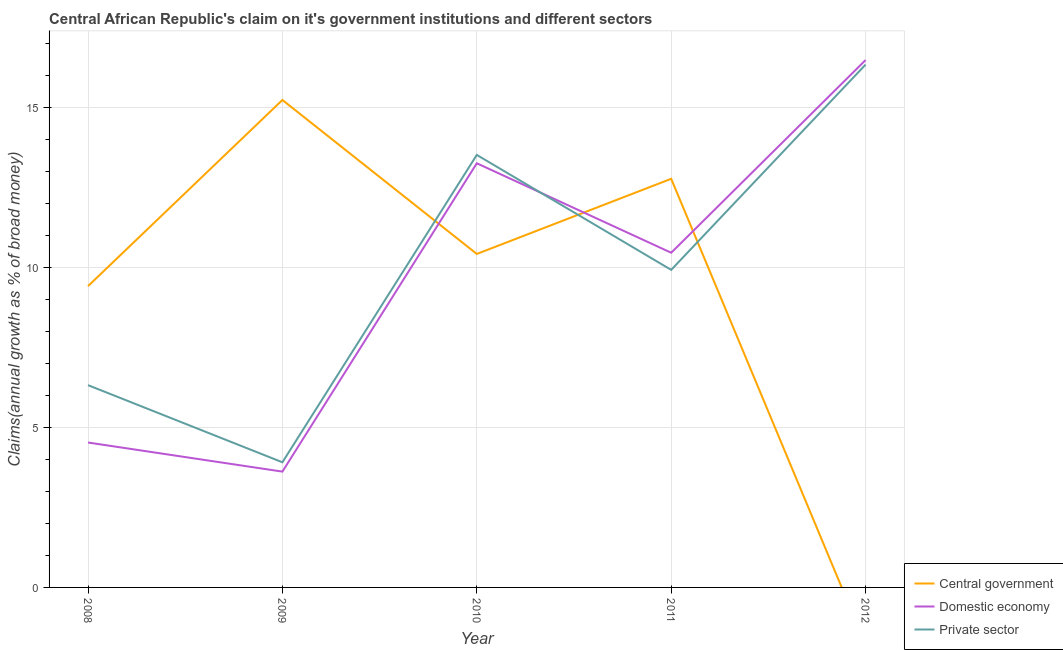What is the percentage of claim on the domestic economy in 2010?
Your answer should be compact. 13.27. Across all years, what is the maximum percentage of claim on the central government?
Provide a succinct answer. 15.25. Across all years, what is the minimum percentage of claim on the domestic economy?
Provide a short and direct response. 3.62. What is the total percentage of claim on the private sector in the graph?
Provide a succinct answer. 50.06. What is the difference between the percentage of claim on the domestic economy in 2008 and that in 2011?
Provide a succinct answer. -5.94. What is the difference between the percentage of claim on the central government in 2012 and the percentage of claim on the domestic economy in 2011?
Provide a short and direct response. -10.47. What is the average percentage of claim on the domestic economy per year?
Your response must be concise. 9.68. In the year 2011, what is the difference between the percentage of claim on the central government and percentage of claim on the domestic economy?
Provide a succinct answer. 2.31. In how many years, is the percentage of claim on the domestic economy greater than 9 %?
Offer a very short reply. 3. What is the ratio of the percentage of claim on the domestic economy in 2008 to that in 2009?
Offer a terse response. 1.25. Is the percentage of claim on the private sector in 2008 less than that in 2009?
Keep it short and to the point. No. What is the difference between the highest and the second highest percentage of claim on the private sector?
Your answer should be very brief. 2.83. What is the difference between the highest and the lowest percentage of claim on the domestic economy?
Give a very brief answer. 12.87. In how many years, is the percentage of claim on the domestic economy greater than the average percentage of claim on the domestic economy taken over all years?
Ensure brevity in your answer.  3. Does the percentage of claim on the central government monotonically increase over the years?
Keep it short and to the point. No. How many lines are there?
Make the answer very short. 3. What is the difference between two consecutive major ticks on the Y-axis?
Provide a succinct answer. 5. Are the values on the major ticks of Y-axis written in scientific E-notation?
Offer a terse response. No. Does the graph contain grids?
Ensure brevity in your answer.  Yes. How many legend labels are there?
Offer a terse response. 3. What is the title of the graph?
Give a very brief answer. Central African Republic's claim on it's government institutions and different sectors. What is the label or title of the X-axis?
Your response must be concise. Year. What is the label or title of the Y-axis?
Offer a terse response. Claims(annual growth as % of broad money). What is the Claims(annual growth as % of broad money) in Central government in 2008?
Give a very brief answer. 9.42. What is the Claims(annual growth as % of broad money) of Domestic economy in 2008?
Your response must be concise. 4.53. What is the Claims(annual growth as % of broad money) of Private sector in 2008?
Give a very brief answer. 6.33. What is the Claims(annual growth as % of broad money) of Central government in 2009?
Provide a succinct answer. 15.25. What is the Claims(annual growth as % of broad money) of Domestic economy in 2009?
Your answer should be very brief. 3.62. What is the Claims(annual growth as % of broad money) of Private sector in 2009?
Offer a terse response. 3.91. What is the Claims(annual growth as % of broad money) in Central government in 2010?
Provide a succinct answer. 10.43. What is the Claims(annual growth as % of broad money) in Domestic economy in 2010?
Provide a succinct answer. 13.27. What is the Claims(annual growth as % of broad money) in Private sector in 2010?
Make the answer very short. 13.53. What is the Claims(annual growth as % of broad money) of Central government in 2011?
Ensure brevity in your answer.  12.78. What is the Claims(annual growth as % of broad money) in Domestic economy in 2011?
Give a very brief answer. 10.47. What is the Claims(annual growth as % of broad money) in Private sector in 2011?
Provide a short and direct response. 9.93. What is the Claims(annual growth as % of broad money) in Central government in 2012?
Ensure brevity in your answer.  0. What is the Claims(annual growth as % of broad money) of Domestic economy in 2012?
Make the answer very short. 16.5. What is the Claims(annual growth as % of broad money) of Private sector in 2012?
Provide a short and direct response. 16.35. Across all years, what is the maximum Claims(annual growth as % of broad money) of Central government?
Your answer should be compact. 15.25. Across all years, what is the maximum Claims(annual growth as % of broad money) of Domestic economy?
Make the answer very short. 16.5. Across all years, what is the maximum Claims(annual growth as % of broad money) of Private sector?
Provide a succinct answer. 16.35. Across all years, what is the minimum Claims(annual growth as % of broad money) in Domestic economy?
Give a very brief answer. 3.62. Across all years, what is the minimum Claims(annual growth as % of broad money) in Private sector?
Ensure brevity in your answer.  3.91. What is the total Claims(annual growth as % of broad money) of Central government in the graph?
Your response must be concise. 47.88. What is the total Claims(annual growth as % of broad money) in Domestic economy in the graph?
Make the answer very short. 48.39. What is the total Claims(annual growth as % of broad money) in Private sector in the graph?
Ensure brevity in your answer.  50.06. What is the difference between the Claims(annual growth as % of broad money) of Central government in 2008 and that in 2009?
Provide a short and direct response. -5.82. What is the difference between the Claims(annual growth as % of broad money) of Domestic economy in 2008 and that in 2009?
Your answer should be compact. 0.91. What is the difference between the Claims(annual growth as % of broad money) of Private sector in 2008 and that in 2009?
Ensure brevity in your answer.  2.41. What is the difference between the Claims(annual growth as % of broad money) in Central government in 2008 and that in 2010?
Give a very brief answer. -1.01. What is the difference between the Claims(annual growth as % of broad money) of Domestic economy in 2008 and that in 2010?
Provide a short and direct response. -8.73. What is the difference between the Claims(annual growth as % of broad money) in Private sector in 2008 and that in 2010?
Your response must be concise. -7.2. What is the difference between the Claims(annual growth as % of broad money) of Central government in 2008 and that in 2011?
Give a very brief answer. -3.36. What is the difference between the Claims(annual growth as % of broad money) in Domestic economy in 2008 and that in 2011?
Your answer should be compact. -5.94. What is the difference between the Claims(annual growth as % of broad money) of Private sector in 2008 and that in 2011?
Provide a short and direct response. -3.61. What is the difference between the Claims(annual growth as % of broad money) in Domestic economy in 2008 and that in 2012?
Provide a succinct answer. -11.96. What is the difference between the Claims(annual growth as % of broad money) of Private sector in 2008 and that in 2012?
Provide a succinct answer. -10.03. What is the difference between the Claims(annual growth as % of broad money) in Central government in 2009 and that in 2010?
Provide a succinct answer. 4.82. What is the difference between the Claims(annual growth as % of broad money) of Domestic economy in 2009 and that in 2010?
Provide a short and direct response. -9.64. What is the difference between the Claims(annual growth as % of broad money) in Private sector in 2009 and that in 2010?
Offer a very short reply. -9.61. What is the difference between the Claims(annual growth as % of broad money) in Central government in 2009 and that in 2011?
Keep it short and to the point. 2.47. What is the difference between the Claims(annual growth as % of broad money) in Domestic economy in 2009 and that in 2011?
Your answer should be compact. -6.85. What is the difference between the Claims(annual growth as % of broad money) of Private sector in 2009 and that in 2011?
Make the answer very short. -6.02. What is the difference between the Claims(annual growth as % of broad money) of Domestic economy in 2009 and that in 2012?
Your answer should be compact. -12.87. What is the difference between the Claims(annual growth as % of broad money) of Private sector in 2009 and that in 2012?
Provide a succinct answer. -12.44. What is the difference between the Claims(annual growth as % of broad money) of Central government in 2010 and that in 2011?
Make the answer very short. -2.35. What is the difference between the Claims(annual growth as % of broad money) of Domestic economy in 2010 and that in 2011?
Make the answer very short. 2.8. What is the difference between the Claims(annual growth as % of broad money) in Private sector in 2010 and that in 2011?
Your answer should be very brief. 3.6. What is the difference between the Claims(annual growth as % of broad money) in Domestic economy in 2010 and that in 2012?
Your answer should be very brief. -3.23. What is the difference between the Claims(annual growth as % of broad money) in Private sector in 2010 and that in 2012?
Provide a short and direct response. -2.83. What is the difference between the Claims(annual growth as % of broad money) in Domestic economy in 2011 and that in 2012?
Make the answer very short. -6.03. What is the difference between the Claims(annual growth as % of broad money) in Private sector in 2011 and that in 2012?
Your response must be concise. -6.42. What is the difference between the Claims(annual growth as % of broad money) in Central government in 2008 and the Claims(annual growth as % of broad money) in Domestic economy in 2009?
Offer a terse response. 5.8. What is the difference between the Claims(annual growth as % of broad money) in Central government in 2008 and the Claims(annual growth as % of broad money) in Private sector in 2009?
Provide a short and direct response. 5.51. What is the difference between the Claims(annual growth as % of broad money) in Domestic economy in 2008 and the Claims(annual growth as % of broad money) in Private sector in 2009?
Provide a short and direct response. 0.62. What is the difference between the Claims(annual growth as % of broad money) in Central government in 2008 and the Claims(annual growth as % of broad money) in Domestic economy in 2010?
Ensure brevity in your answer.  -3.84. What is the difference between the Claims(annual growth as % of broad money) in Central government in 2008 and the Claims(annual growth as % of broad money) in Private sector in 2010?
Provide a succinct answer. -4.1. What is the difference between the Claims(annual growth as % of broad money) in Domestic economy in 2008 and the Claims(annual growth as % of broad money) in Private sector in 2010?
Give a very brief answer. -9. What is the difference between the Claims(annual growth as % of broad money) in Central government in 2008 and the Claims(annual growth as % of broad money) in Domestic economy in 2011?
Give a very brief answer. -1.04. What is the difference between the Claims(annual growth as % of broad money) in Central government in 2008 and the Claims(annual growth as % of broad money) in Private sector in 2011?
Ensure brevity in your answer.  -0.51. What is the difference between the Claims(annual growth as % of broad money) of Domestic economy in 2008 and the Claims(annual growth as % of broad money) of Private sector in 2011?
Your response must be concise. -5.4. What is the difference between the Claims(annual growth as % of broad money) of Central government in 2008 and the Claims(annual growth as % of broad money) of Domestic economy in 2012?
Offer a terse response. -7.07. What is the difference between the Claims(annual growth as % of broad money) of Central government in 2008 and the Claims(annual growth as % of broad money) of Private sector in 2012?
Provide a succinct answer. -6.93. What is the difference between the Claims(annual growth as % of broad money) in Domestic economy in 2008 and the Claims(annual growth as % of broad money) in Private sector in 2012?
Your response must be concise. -11.82. What is the difference between the Claims(annual growth as % of broad money) in Central government in 2009 and the Claims(annual growth as % of broad money) in Domestic economy in 2010?
Offer a very short reply. 1.98. What is the difference between the Claims(annual growth as % of broad money) in Central government in 2009 and the Claims(annual growth as % of broad money) in Private sector in 2010?
Offer a very short reply. 1.72. What is the difference between the Claims(annual growth as % of broad money) in Domestic economy in 2009 and the Claims(annual growth as % of broad money) in Private sector in 2010?
Offer a very short reply. -9.91. What is the difference between the Claims(annual growth as % of broad money) of Central government in 2009 and the Claims(annual growth as % of broad money) of Domestic economy in 2011?
Offer a very short reply. 4.78. What is the difference between the Claims(annual growth as % of broad money) in Central government in 2009 and the Claims(annual growth as % of broad money) in Private sector in 2011?
Give a very brief answer. 5.31. What is the difference between the Claims(annual growth as % of broad money) of Domestic economy in 2009 and the Claims(annual growth as % of broad money) of Private sector in 2011?
Offer a terse response. -6.31. What is the difference between the Claims(annual growth as % of broad money) of Central government in 2009 and the Claims(annual growth as % of broad money) of Domestic economy in 2012?
Provide a short and direct response. -1.25. What is the difference between the Claims(annual growth as % of broad money) of Central government in 2009 and the Claims(annual growth as % of broad money) of Private sector in 2012?
Provide a short and direct response. -1.11. What is the difference between the Claims(annual growth as % of broad money) in Domestic economy in 2009 and the Claims(annual growth as % of broad money) in Private sector in 2012?
Ensure brevity in your answer.  -12.73. What is the difference between the Claims(annual growth as % of broad money) of Central government in 2010 and the Claims(annual growth as % of broad money) of Domestic economy in 2011?
Provide a succinct answer. -0.04. What is the difference between the Claims(annual growth as % of broad money) in Central government in 2010 and the Claims(annual growth as % of broad money) in Private sector in 2011?
Offer a very short reply. 0.5. What is the difference between the Claims(annual growth as % of broad money) of Domestic economy in 2010 and the Claims(annual growth as % of broad money) of Private sector in 2011?
Make the answer very short. 3.33. What is the difference between the Claims(annual growth as % of broad money) of Central government in 2010 and the Claims(annual growth as % of broad money) of Domestic economy in 2012?
Make the answer very short. -6.06. What is the difference between the Claims(annual growth as % of broad money) of Central government in 2010 and the Claims(annual growth as % of broad money) of Private sector in 2012?
Your answer should be compact. -5.92. What is the difference between the Claims(annual growth as % of broad money) in Domestic economy in 2010 and the Claims(annual growth as % of broad money) in Private sector in 2012?
Provide a succinct answer. -3.09. What is the difference between the Claims(annual growth as % of broad money) of Central government in 2011 and the Claims(annual growth as % of broad money) of Domestic economy in 2012?
Ensure brevity in your answer.  -3.71. What is the difference between the Claims(annual growth as % of broad money) of Central government in 2011 and the Claims(annual growth as % of broad money) of Private sector in 2012?
Your answer should be compact. -3.57. What is the difference between the Claims(annual growth as % of broad money) of Domestic economy in 2011 and the Claims(annual growth as % of broad money) of Private sector in 2012?
Provide a succinct answer. -5.88. What is the average Claims(annual growth as % of broad money) in Central government per year?
Give a very brief answer. 9.58. What is the average Claims(annual growth as % of broad money) in Domestic economy per year?
Provide a short and direct response. 9.68. What is the average Claims(annual growth as % of broad money) in Private sector per year?
Give a very brief answer. 10.01. In the year 2008, what is the difference between the Claims(annual growth as % of broad money) in Central government and Claims(annual growth as % of broad money) in Domestic economy?
Provide a succinct answer. 4.89. In the year 2008, what is the difference between the Claims(annual growth as % of broad money) of Central government and Claims(annual growth as % of broad money) of Private sector?
Give a very brief answer. 3.1. In the year 2008, what is the difference between the Claims(annual growth as % of broad money) of Domestic economy and Claims(annual growth as % of broad money) of Private sector?
Make the answer very short. -1.79. In the year 2009, what is the difference between the Claims(annual growth as % of broad money) in Central government and Claims(annual growth as % of broad money) in Domestic economy?
Provide a succinct answer. 11.62. In the year 2009, what is the difference between the Claims(annual growth as % of broad money) of Central government and Claims(annual growth as % of broad money) of Private sector?
Your answer should be compact. 11.33. In the year 2009, what is the difference between the Claims(annual growth as % of broad money) of Domestic economy and Claims(annual growth as % of broad money) of Private sector?
Your answer should be compact. -0.29. In the year 2010, what is the difference between the Claims(annual growth as % of broad money) in Central government and Claims(annual growth as % of broad money) in Domestic economy?
Ensure brevity in your answer.  -2.84. In the year 2010, what is the difference between the Claims(annual growth as % of broad money) in Central government and Claims(annual growth as % of broad money) in Private sector?
Keep it short and to the point. -3.1. In the year 2010, what is the difference between the Claims(annual growth as % of broad money) in Domestic economy and Claims(annual growth as % of broad money) in Private sector?
Make the answer very short. -0.26. In the year 2011, what is the difference between the Claims(annual growth as % of broad money) in Central government and Claims(annual growth as % of broad money) in Domestic economy?
Give a very brief answer. 2.31. In the year 2011, what is the difference between the Claims(annual growth as % of broad money) in Central government and Claims(annual growth as % of broad money) in Private sector?
Give a very brief answer. 2.85. In the year 2011, what is the difference between the Claims(annual growth as % of broad money) of Domestic economy and Claims(annual growth as % of broad money) of Private sector?
Offer a terse response. 0.54. In the year 2012, what is the difference between the Claims(annual growth as % of broad money) of Domestic economy and Claims(annual growth as % of broad money) of Private sector?
Give a very brief answer. 0.14. What is the ratio of the Claims(annual growth as % of broad money) in Central government in 2008 to that in 2009?
Your answer should be compact. 0.62. What is the ratio of the Claims(annual growth as % of broad money) in Domestic economy in 2008 to that in 2009?
Your answer should be very brief. 1.25. What is the ratio of the Claims(annual growth as % of broad money) of Private sector in 2008 to that in 2009?
Offer a very short reply. 1.62. What is the ratio of the Claims(annual growth as % of broad money) of Central government in 2008 to that in 2010?
Keep it short and to the point. 0.9. What is the ratio of the Claims(annual growth as % of broad money) in Domestic economy in 2008 to that in 2010?
Keep it short and to the point. 0.34. What is the ratio of the Claims(annual growth as % of broad money) of Private sector in 2008 to that in 2010?
Your response must be concise. 0.47. What is the ratio of the Claims(annual growth as % of broad money) of Central government in 2008 to that in 2011?
Your answer should be compact. 0.74. What is the ratio of the Claims(annual growth as % of broad money) of Domestic economy in 2008 to that in 2011?
Offer a very short reply. 0.43. What is the ratio of the Claims(annual growth as % of broad money) of Private sector in 2008 to that in 2011?
Your answer should be very brief. 0.64. What is the ratio of the Claims(annual growth as % of broad money) of Domestic economy in 2008 to that in 2012?
Your answer should be compact. 0.27. What is the ratio of the Claims(annual growth as % of broad money) of Private sector in 2008 to that in 2012?
Your response must be concise. 0.39. What is the ratio of the Claims(annual growth as % of broad money) of Central government in 2009 to that in 2010?
Keep it short and to the point. 1.46. What is the ratio of the Claims(annual growth as % of broad money) of Domestic economy in 2009 to that in 2010?
Your response must be concise. 0.27. What is the ratio of the Claims(annual growth as % of broad money) of Private sector in 2009 to that in 2010?
Keep it short and to the point. 0.29. What is the ratio of the Claims(annual growth as % of broad money) in Central government in 2009 to that in 2011?
Keep it short and to the point. 1.19. What is the ratio of the Claims(annual growth as % of broad money) of Domestic economy in 2009 to that in 2011?
Your response must be concise. 0.35. What is the ratio of the Claims(annual growth as % of broad money) of Private sector in 2009 to that in 2011?
Ensure brevity in your answer.  0.39. What is the ratio of the Claims(annual growth as % of broad money) in Domestic economy in 2009 to that in 2012?
Provide a short and direct response. 0.22. What is the ratio of the Claims(annual growth as % of broad money) in Private sector in 2009 to that in 2012?
Your answer should be very brief. 0.24. What is the ratio of the Claims(annual growth as % of broad money) of Central government in 2010 to that in 2011?
Make the answer very short. 0.82. What is the ratio of the Claims(annual growth as % of broad money) of Domestic economy in 2010 to that in 2011?
Keep it short and to the point. 1.27. What is the ratio of the Claims(annual growth as % of broad money) of Private sector in 2010 to that in 2011?
Make the answer very short. 1.36. What is the ratio of the Claims(annual growth as % of broad money) in Domestic economy in 2010 to that in 2012?
Keep it short and to the point. 0.8. What is the ratio of the Claims(annual growth as % of broad money) of Private sector in 2010 to that in 2012?
Offer a very short reply. 0.83. What is the ratio of the Claims(annual growth as % of broad money) in Domestic economy in 2011 to that in 2012?
Offer a very short reply. 0.63. What is the ratio of the Claims(annual growth as % of broad money) of Private sector in 2011 to that in 2012?
Make the answer very short. 0.61. What is the difference between the highest and the second highest Claims(annual growth as % of broad money) of Central government?
Offer a terse response. 2.47. What is the difference between the highest and the second highest Claims(annual growth as % of broad money) of Domestic economy?
Give a very brief answer. 3.23. What is the difference between the highest and the second highest Claims(annual growth as % of broad money) of Private sector?
Provide a short and direct response. 2.83. What is the difference between the highest and the lowest Claims(annual growth as % of broad money) of Central government?
Your answer should be very brief. 15.25. What is the difference between the highest and the lowest Claims(annual growth as % of broad money) of Domestic economy?
Your response must be concise. 12.87. What is the difference between the highest and the lowest Claims(annual growth as % of broad money) in Private sector?
Give a very brief answer. 12.44. 